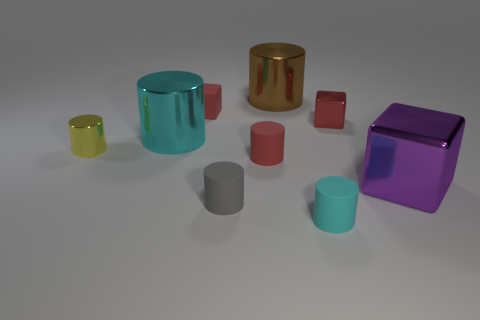Add 1 gray objects. How many objects exist? 10 Subtract all purple blocks. How many blocks are left? 2 Subtract all small metallic cubes. How many cubes are left? 2 Subtract 1 purple blocks. How many objects are left? 8 Subtract all cylinders. How many objects are left? 3 Subtract 2 cubes. How many cubes are left? 1 Subtract all yellow cylinders. Subtract all blue balls. How many cylinders are left? 5 Subtract all blue cylinders. How many red blocks are left? 2 Subtract all tiny red matte objects. Subtract all yellow objects. How many objects are left? 6 Add 1 cyan matte cylinders. How many cyan matte cylinders are left? 2 